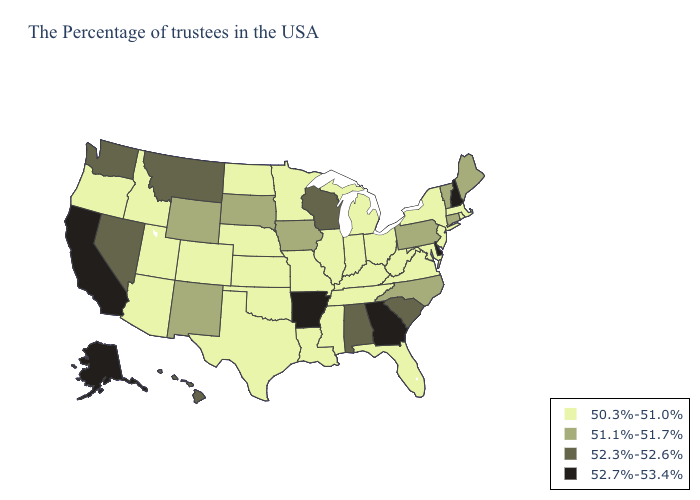What is the highest value in the USA?
Be succinct. 52.7%-53.4%. Name the states that have a value in the range 50.3%-51.0%?
Keep it brief. Massachusetts, Rhode Island, New York, New Jersey, Maryland, Virginia, West Virginia, Ohio, Florida, Michigan, Kentucky, Indiana, Tennessee, Illinois, Mississippi, Louisiana, Missouri, Minnesota, Kansas, Nebraska, Oklahoma, Texas, North Dakota, Colorado, Utah, Arizona, Idaho, Oregon. Name the states that have a value in the range 52.3%-52.6%?
Short answer required. South Carolina, Alabama, Wisconsin, Montana, Nevada, Washington, Hawaii. What is the highest value in the South ?
Answer briefly. 52.7%-53.4%. Name the states that have a value in the range 50.3%-51.0%?
Write a very short answer. Massachusetts, Rhode Island, New York, New Jersey, Maryland, Virginia, West Virginia, Ohio, Florida, Michigan, Kentucky, Indiana, Tennessee, Illinois, Mississippi, Louisiana, Missouri, Minnesota, Kansas, Nebraska, Oklahoma, Texas, North Dakota, Colorado, Utah, Arizona, Idaho, Oregon. Does Arizona have the lowest value in the West?
Keep it brief. Yes. Does Michigan have the highest value in the USA?
Be succinct. No. Name the states that have a value in the range 51.1%-51.7%?
Be succinct. Maine, Vermont, Connecticut, Pennsylvania, North Carolina, Iowa, South Dakota, Wyoming, New Mexico. Which states have the highest value in the USA?
Concise answer only. New Hampshire, Delaware, Georgia, Arkansas, California, Alaska. Name the states that have a value in the range 51.1%-51.7%?
Quick response, please. Maine, Vermont, Connecticut, Pennsylvania, North Carolina, Iowa, South Dakota, Wyoming, New Mexico. Name the states that have a value in the range 52.3%-52.6%?
Write a very short answer. South Carolina, Alabama, Wisconsin, Montana, Nevada, Washington, Hawaii. What is the value of Alaska?
Concise answer only. 52.7%-53.4%. Which states have the lowest value in the USA?
Give a very brief answer. Massachusetts, Rhode Island, New York, New Jersey, Maryland, Virginia, West Virginia, Ohio, Florida, Michigan, Kentucky, Indiana, Tennessee, Illinois, Mississippi, Louisiana, Missouri, Minnesota, Kansas, Nebraska, Oklahoma, Texas, North Dakota, Colorado, Utah, Arizona, Idaho, Oregon. What is the highest value in the USA?
Be succinct. 52.7%-53.4%. 